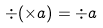<formula> <loc_0><loc_0><loc_500><loc_500>\div ( \times a ) = \div a</formula> 